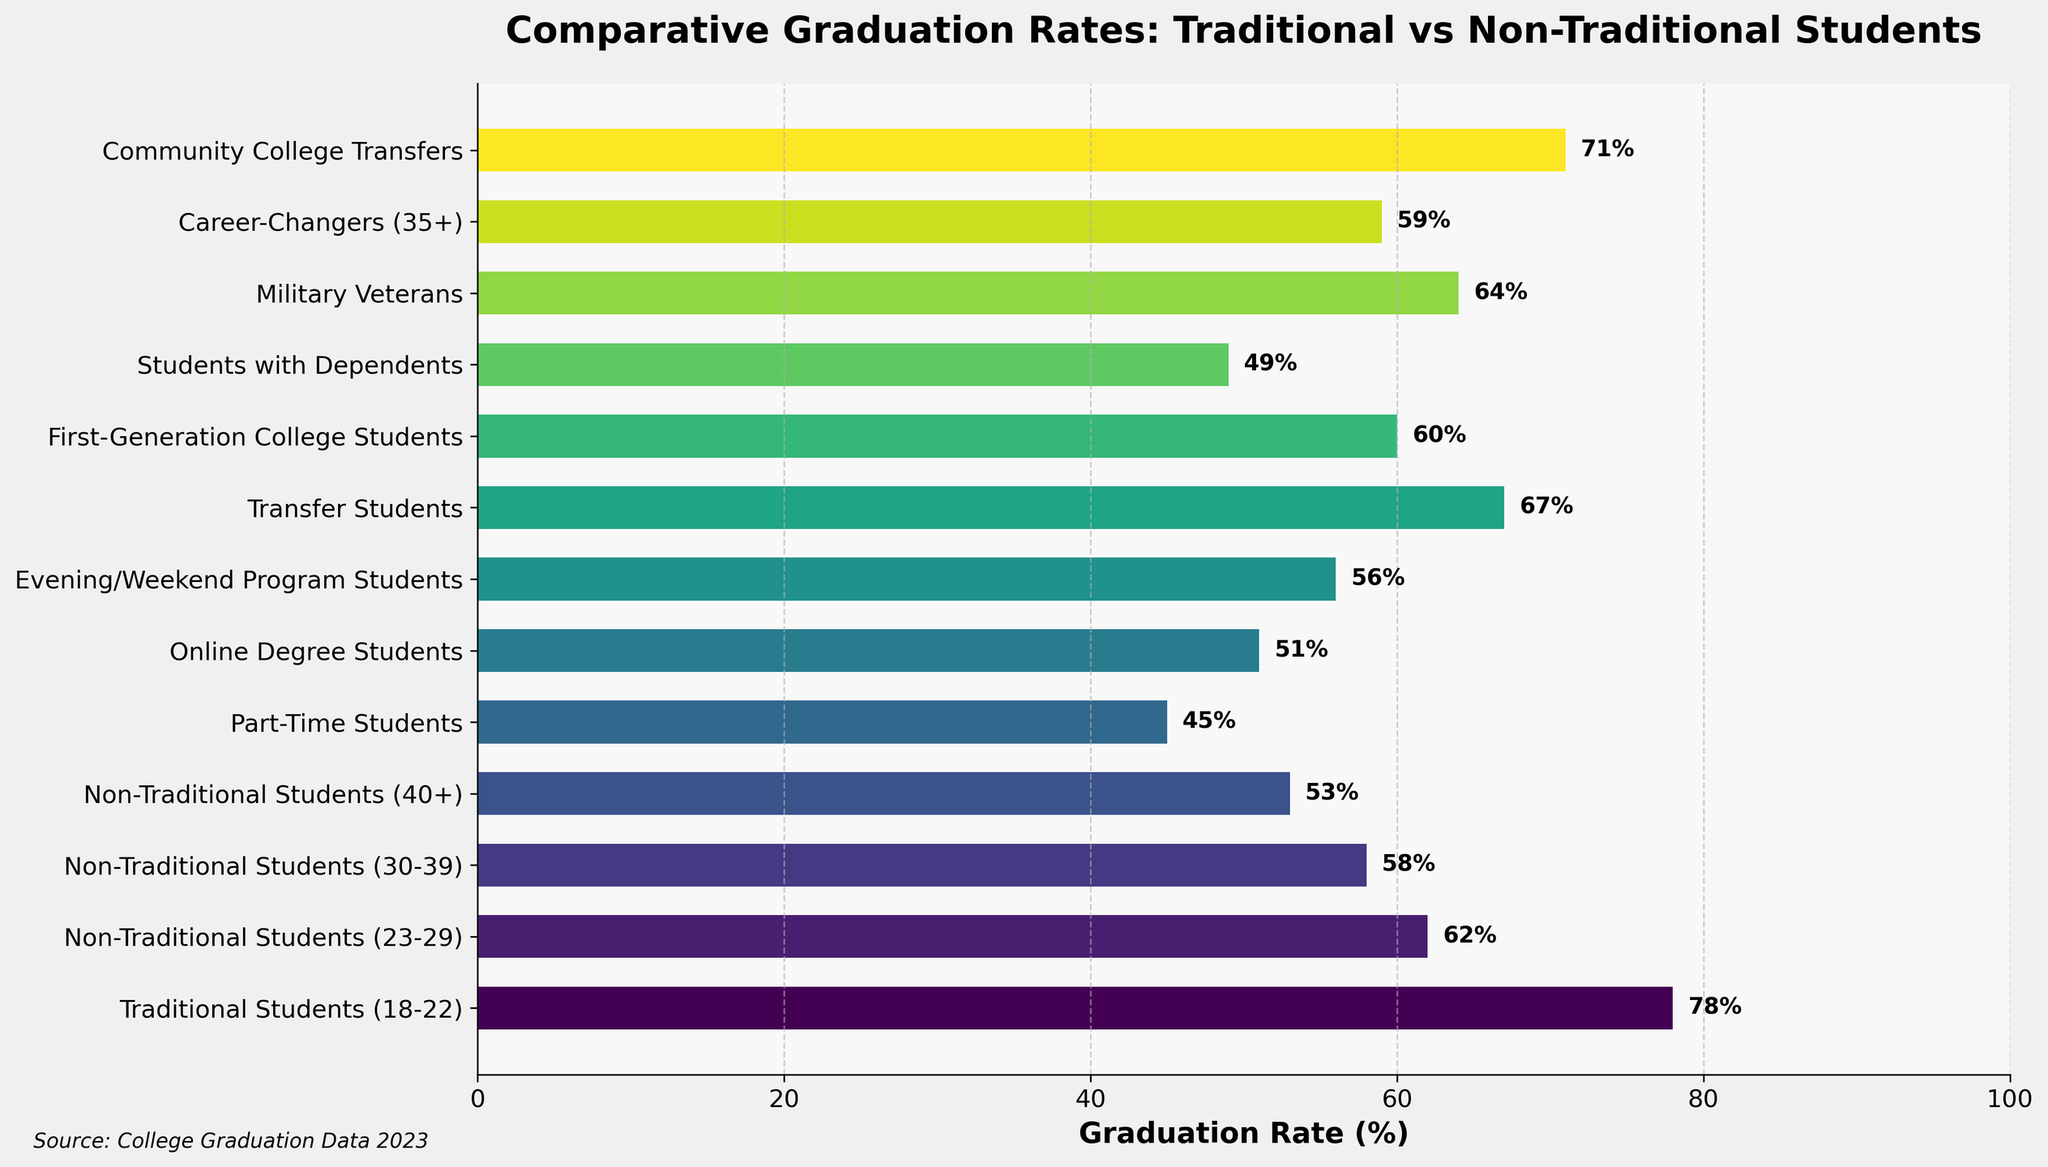Which student type has the highest graduation rate? The bar for Traditional Students (18-22) is the longest, indicating the highest graduation rate.
Answer: Traditional Students (18-22) Which student type has the lowest graduation rate? The bar for Part-Time Students is the shortest, indicating the lowest graduation rate.
Answer: Part-Time Students Compare the graduation rates of Traditional Students (18-22) and Non-Traditional Students (40+). The graduation rate for Traditional Students (18-22) is 78%, while for Non-Traditional Students (40+), it is 53%.
Answer: Traditional Students (18-22) have a higher rate than Non-Traditional Students (40+) Which student type has a graduation rate closest to 60%? The graduation rates for Non-Traditional Students (23-29), First-Generation College Students, and Career-Changers (35+) are near 60%. Non-Traditional Students (23-29) have 62%, First-Generation College Students have 60%, and Career-Changers (35+) have 59%. First-Generation College Students is exactly 60%.
Answer: First-Generation College Students What is the difference in graduation rates between Part-Time Students and Community College Transfers? The graduation rate for Part-Time Students is 45%, and for Community College Transfers, it is 71%. The difference is 71% - 45% = 26%.
Answer: 26% How does the graduation rate of Students with Dependents compare to Evening/Weekend Program Students? Students with Dependents have a graduation rate of 49%, whereas Evening/Weekend Program Students have a graduation rate of 56%.
Answer: Evening/Weekend Program Students have a higher graduation rate What is the average graduation rate of all student types depicted? Add all the graduation rates and divide by the number of student types: (78 + 62 + 58 + 53 + 45 + 51 + 56 + 67 + 60 + 49 + 64 + 59 + 71) / 13 = 59.23%
Answer: 59.23% Which student types have graduation rates greater than 60%? The bar lengths for Traditional Students (18-22), Transfer Students, and Community College Transfers exceed the 60% mark.
Answer: Traditional Students (18-22), Transfer Students, Community College Transfers Are there any student types with the identical graduation rates? By examining the bars, no two types of students have the exact same graduation rate.
Answer: No How much higher is the graduation rate for Military Veterans compared to Online Degree Students? The graduation rate for Military Veterans is 64%, while for Online Degree Students, it’s 51%. The difference is 64% - 51% = 13%.
Answer: 13% 